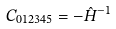<formula> <loc_0><loc_0><loc_500><loc_500>C _ { 0 1 2 3 4 5 } = - \hat { H } ^ { - 1 }</formula> 